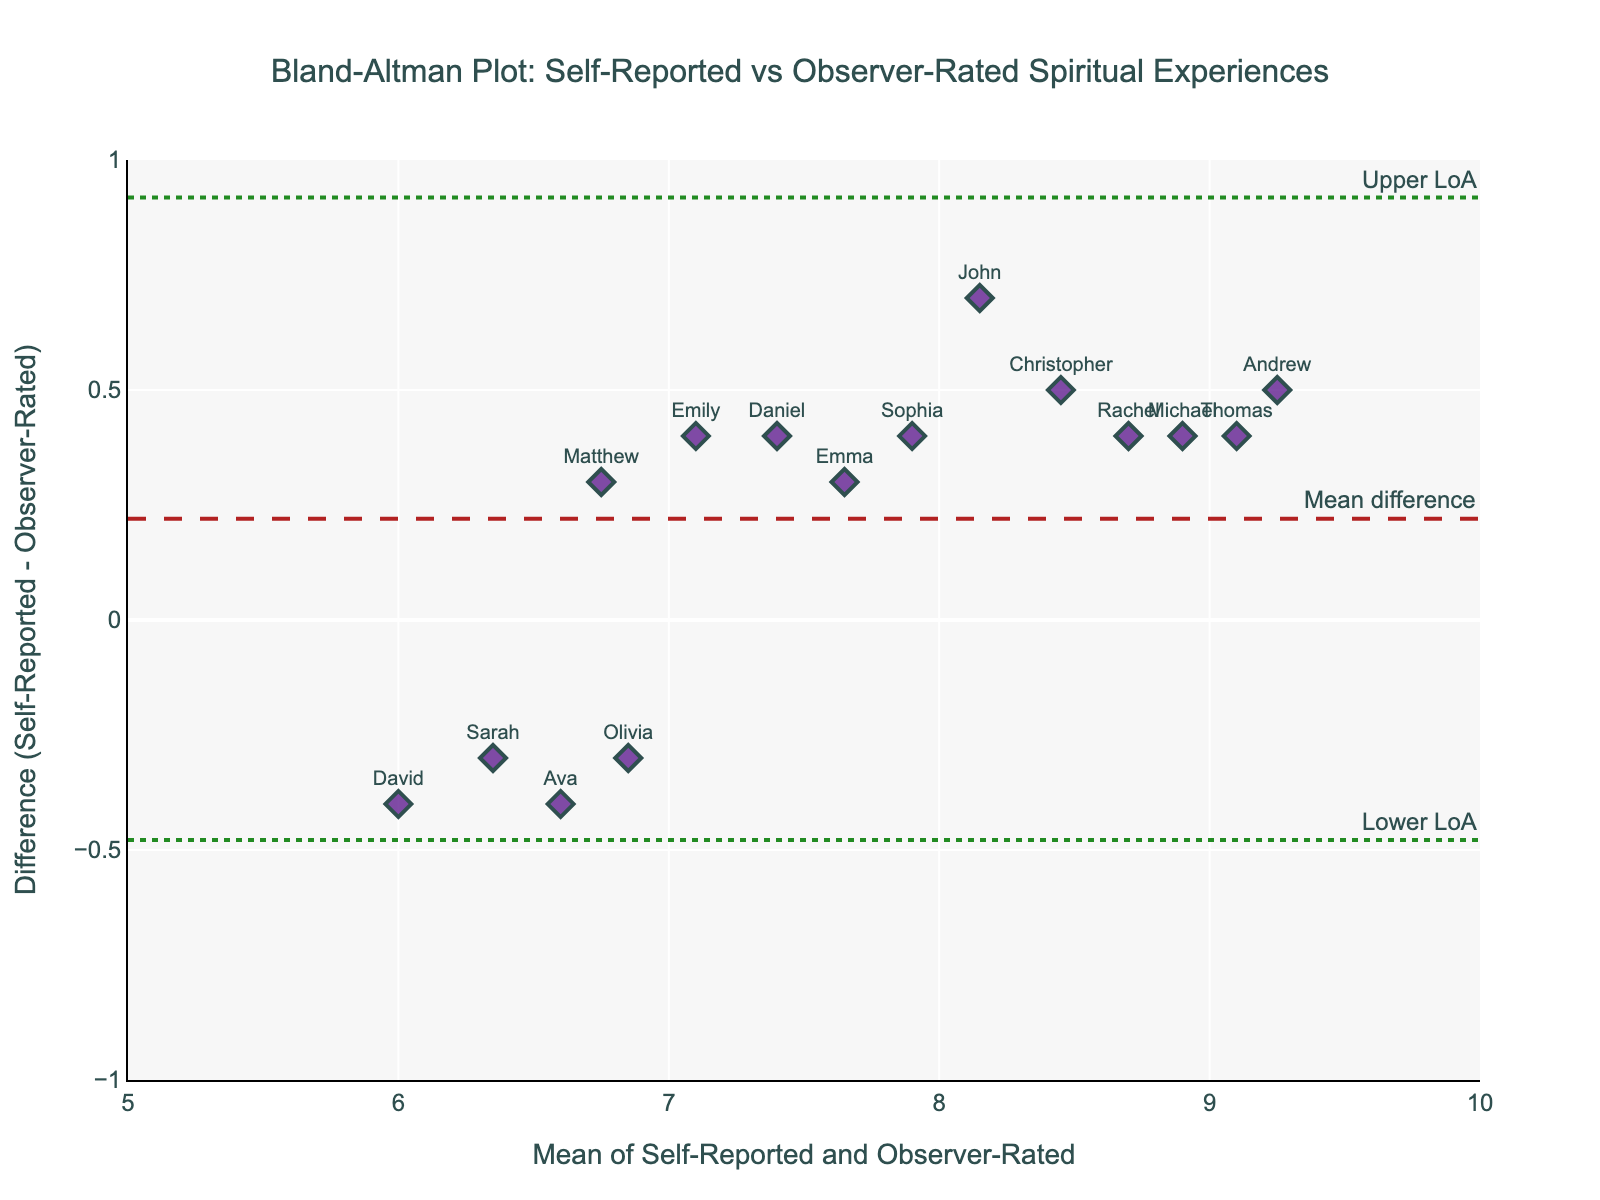How many participants are shown in the plot? Count the number of markers or labels corresponding to participants in the scatter plot.
Answer: 15 What is the title of the plot? Look at the title text at the top of the plot.
Answer: Bland-Altman Plot: Self-Reported vs Observer-Rated Spiritual Experiences Which participant has the highest self-reported experience? Identify the point with the highest value on the x-axis where the self-reported value is 9.5, then refer to the label.
Answer: Andrew Which participant has the smallest difference between self-reported and observer-rated experiences? Find the point closest to zero on the y-axis and check the label.
Answer: Sarah What is the mean difference between self-reported and observer-rated experiences? Look at the horizontal line marked "Mean difference" and identify its y-coordinate value.
Answer: 0.1 What are the limits of agreement in the plot? Look at the horizontal lines marked "Lower LoA" and "Upper LoA" and note their y-coordinate values.
Answer: -0.45 and 0.65 What is the difference in spiritual experiences for Sophia? Locate Sophia's marker and read the y-coordinate value where it is positioned.
Answer: 0.4 Which participant has the largest positive difference between self-reported and observer-rated experiences? Find the point with the highest positive y-coordinate and check the label.
Answer: John Are there more points above or below the mean difference line? Count the number of points above and below the line labeled "Mean difference".
Answer: Above What is the x-axis label of the plot? Look at the text at the bottom of the x-axis.
Answer: Mean of Self-Reported and Observer-Rated What range is shown on the y-axis? Look at the range displayed on the y-axis (Difference).
Answer: -1 to 1 